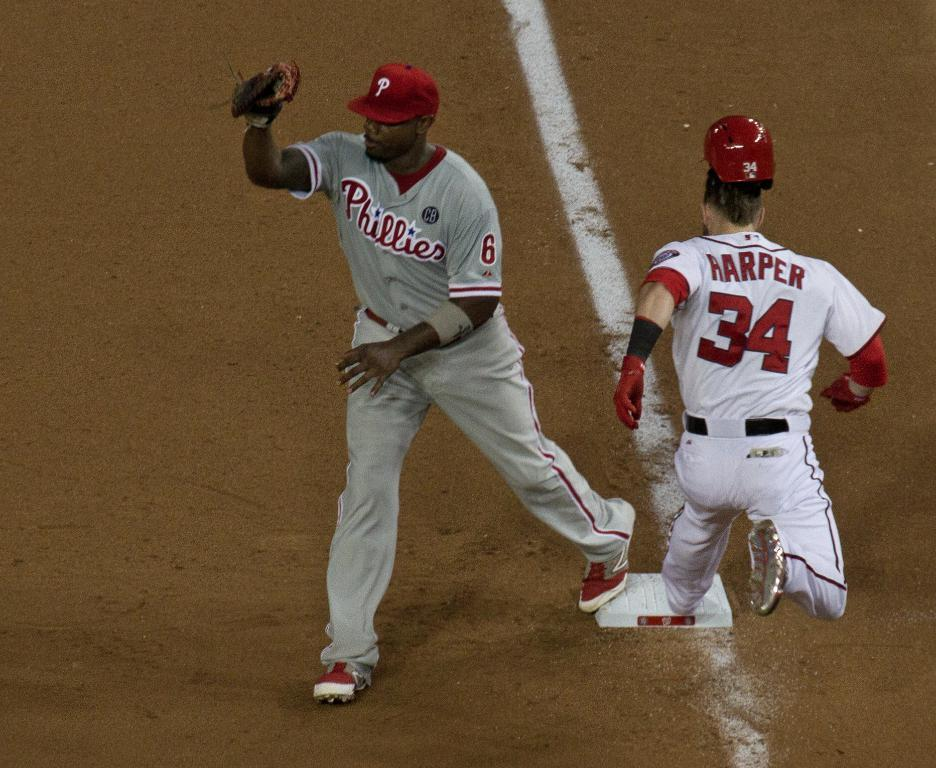<image>
Describe the image concisely. A player from the Phullies stands on base receiving a ball as Harper, the opposing player stretches out to get to the base in time. 